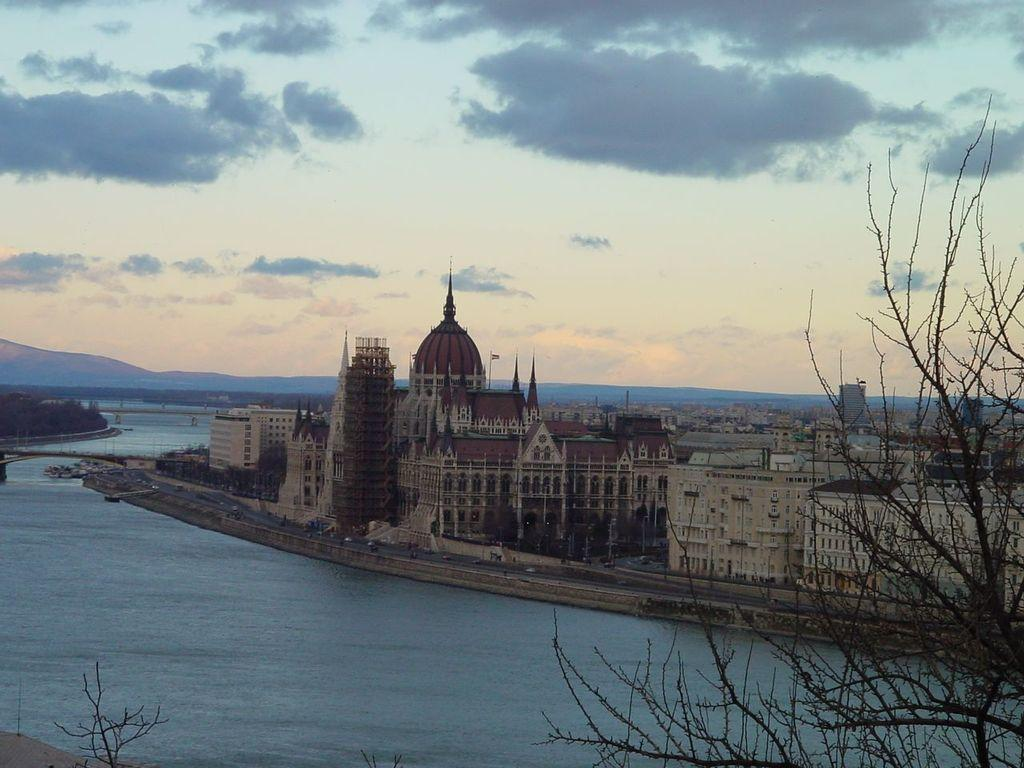What type of natural elements can be seen in the image? There are trees and water visible in the image. What man-made structures are present in the image? There are bridges, a flag, a road, buildings, and hills in the image. What part of the natural environment is visible in the image? The sky is visible in the image. What type of corn can be seen growing near the church in the image? There is no church or corn present in the image. How many bells can be heard ringing in the image? There are no bells or sounds mentioned in the image, so it is not possible to determine how many bells might be ringing. 